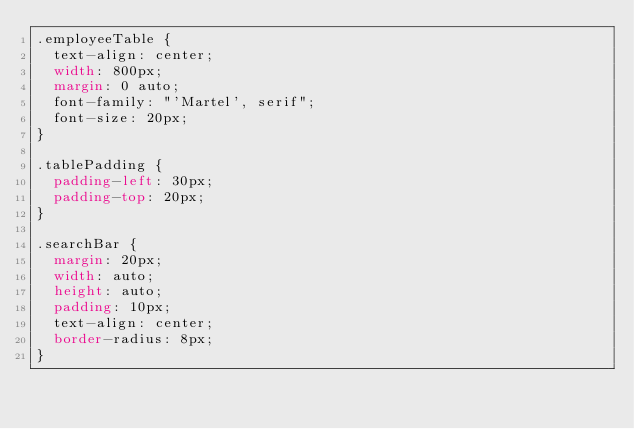<code> <loc_0><loc_0><loc_500><loc_500><_CSS_>.employeeTable {
  text-align: center;
  width: 800px;
  margin: 0 auto;
  font-family: "'Martel', serif";
  font-size: 20px;
}

.tablePadding {
  padding-left: 30px;
  padding-top: 20px;
}

.searchBar {
  margin: 20px;
  width: auto;
  height: auto;
  padding: 10px;
  text-align: center;
  border-radius: 8px;
}
</code> 